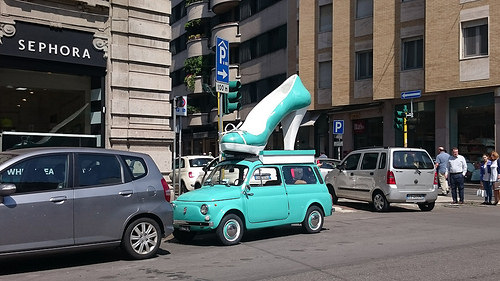<image>
Is there a shoe on the car? Yes. Looking at the image, I can see the shoe is positioned on top of the car, with the car providing support. Is the shoe above the car? Yes. The shoe is positioned above the car in the vertical space, higher up in the scene. 